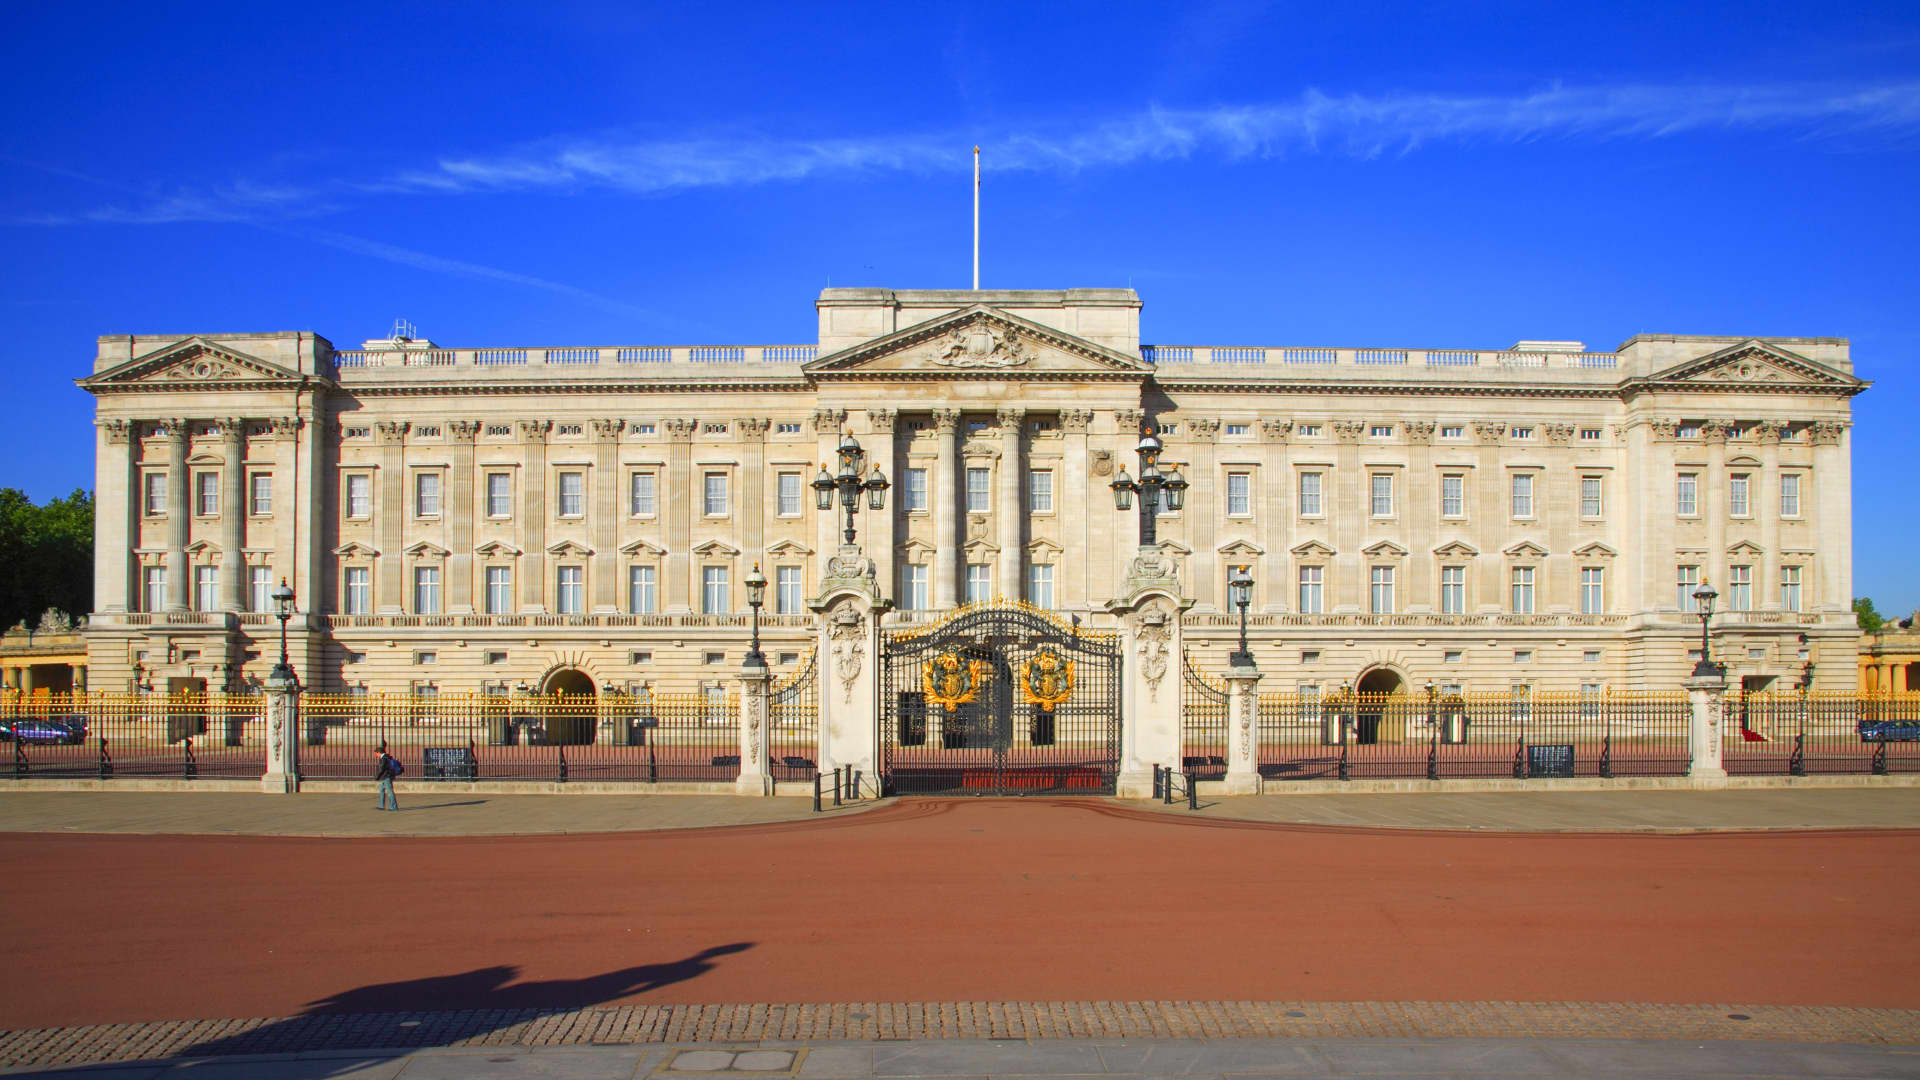What is this photo about? The image showcases the splendid architecture of Buckingham Palace, the official residence and administrative headquarters of the British monarch in London. From this frontal view, the palace’s grandiose design, with its intricate facade and numerous windows, is prominently on display. The Victoria Memorial, standing proudly in the foreground, features a golden angel statue that shines brightly under the sunlight. The pristine blue sky in the background further adds to the image’s serene and majestic quality. Overall, the photograph captures the elegance and historical significance of this iconic landmark, bathed in natural light that highlights its welcoming and imposing aura. 